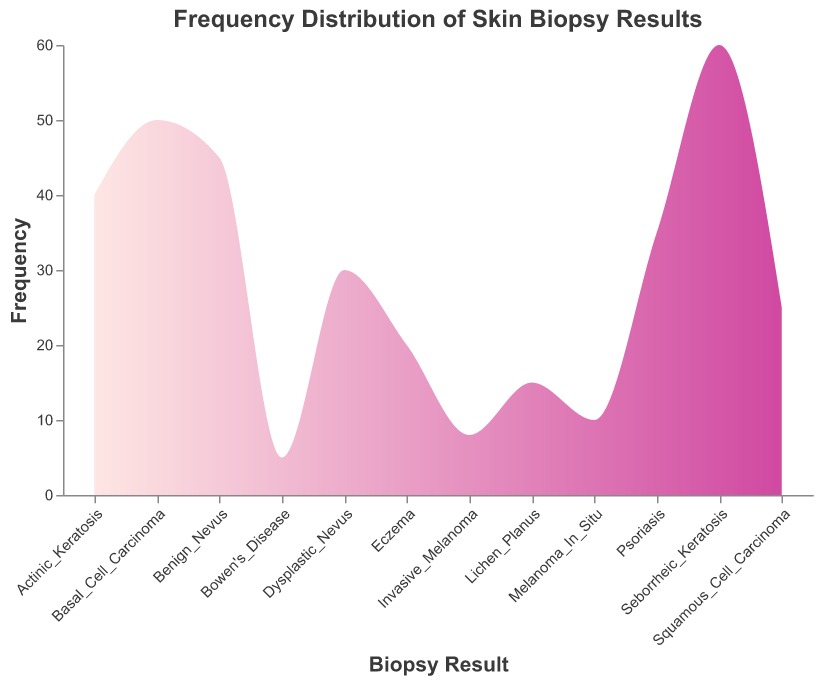What is the title of the plot? The title of the plot is shown at the top and reads "Frequency Distribution of Skin Biopsy Results".
Answer: Frequency Distribution of Skin Biopsy Results Which biopsy result has the highest frequency? By looking at the highest point on the y-axis, "Seborrheic Keratosis" has the highest frequency among all the biopsy results.
Answer: Seborrheic Keratosis How many biopsy results have a frequency greater than 30? The bars for "Benign Nevus", "Dysplastic Nevus", "Basal Cell Carcinoma", "Actinic Keratosis", "Seborrheic Keratosis", and "Psoriasis" exceed 30. Counting them gives us six biopsy results.
Answer: 6 Which biopsy result has the lowest frequency? The biopsy result with the lowest point on the y-axis is "Bowen's Disease".
Answer: Bowen's Disease What is the frequency difference between the highest and lowest biopsy results? The frequency of "Seborrheic Keratosis" is 60 and "Bowen's Disease" is 5. The difference is 60 - 5 = 55.
Answer: 55 Are there more benign or malignant biopsy results? Benign biopsy results include "Benign Nevus", "Dysplastic Nevus", "Seborrheic Keratosis", "Actinic Keratosis", "Psoriasis", "Eczema", and "Lichen Planus". Malignant results appear as "Melanoma In Situ", "Invasive Melanoma", "Basal Cell Carcinoma", "Squamous Cell Carcinoma", and "Bowen's Disease". Counting each category, there are 7 benign and 5 malignant results.
Answer: More benign What is the average frequency of all biopsy results? Summing the frequencies: 45 + 30 + 10 + 8 + 50 + 25 + 40 + 60 + 35 + 20 + 15 + 5 = 343. Dividing by the number of biopsy results (12) gives an average frequency of 343/12 ≈ 28.58.
Answer: 28.58 Which biopsy results have frequencies between 20 and 40? The biopsy results with frequencies in this range are "Dysplastic Nevus", "Squamous Cell Carcinoma", "Actinic Keratosis", "Psoriasis", and "Eczema".
Answer: Dysplastic Nevus, Squamous Cell Carcinoma, Actinic Keratosis, Psoriasis, and Eczema How does the frequency of "Basal Cell Carcinoma" compare to "Squamous Cell Carcinoma"? "Basal Cell Carcinoma" has a frequency of 50 whereas "Squamous Cell Carcinoma" has a frequency of 25. Therefore, "Basal Cell Carcinoma" has double the frequency of "Squamous Cell Carcinoma".
Answer: Double 